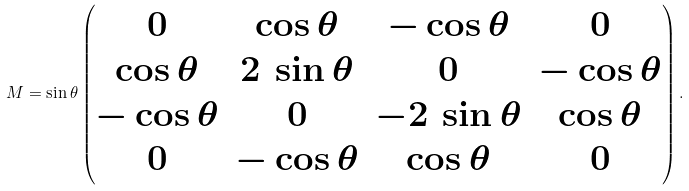<formula> <loc_0><loc_0><loc_500><loc_500>M = \sin \theta \begin{pmatrix} 0 & \cos \theta & - \cos \theta & 0 \\ \cos \theta & 2 \, \sin \theta & 0 & - \cos \theta \\ - \cos \theta & 0 & - 2 \, \sin \theta & \cos \theta \\ 0 & - \cos \theta & \cos \theta & 0 \end{pmatrix} .</formula> 